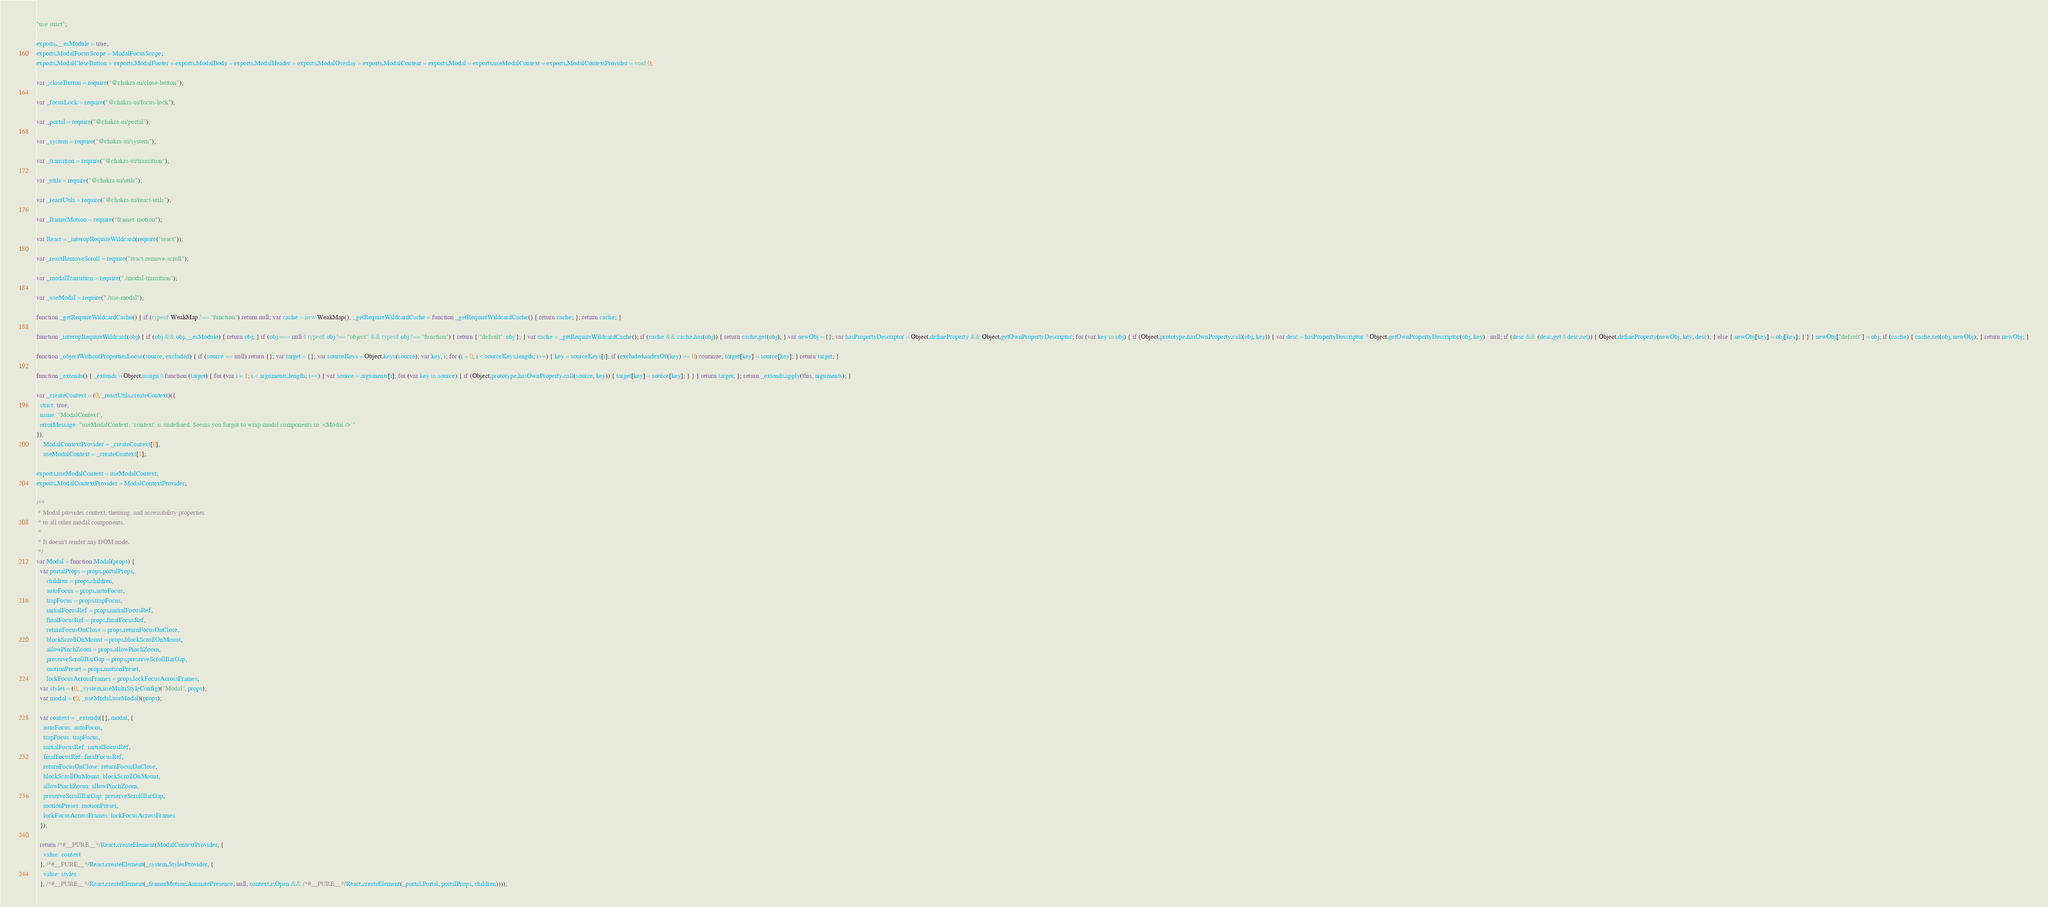Convert code to text. <code><loc_0><loc_0><loc_500><loc_500><_JavaScript_>"use strict";

exports.__esModule = true;
exports.ModalFocusScope = ModalFocusScope;
exports.ModalCloseButton = exports.ModalFooter = exports.ModalBody = exports.ModalHeader = exports.ModalOverlay = exports.ModalContent = exports.Modal = exports.useModalContext = exports.ModalContextProvider = void 0;

var _closeButton = require("@chakra-ui/close-button");

var _focusLock = require("@chakra-ui/focus-lock");

var _portal = require("@chakra-ui/portal");

var _system = require("@chakra-ui/system");

var _transition = require("@chakra-ui/transition");

var _utils = require("@chakra-ui/utils");

var _reactUtils = require("@chakra-ui/react-utils");

var _framerMotion = require("framer-motion");

var React = _interopRequireWildcard(require("react"));

var _reactRemoveScroll = require("react-remove-scroll");

var _modalTransition = require("./modal-transition");

var _useModal = require("./use-modal");

function _getRequireWildcardCache() { if (typeof WeakMap !== "function") return null; var cache = new WeakMap(); _getRequireWildcardCache = function _getRequireWildcardCache() { return cache; }; return cache; }

function _interopRequireWildcard(obj) { if (obj && obj.__esModule) { return obj; } if (obj === null || typeof obj !== "object" && typeof obj !== "function") { return { "default": obj }; } var cache = _getRequireWildcardCache(); if (cache && cache.has(obj)) { return cache.get(obj); } var newObj = {}; var hasPropertyDescriptor = Object.defineProperty && Object.getOwnPropertyDescriptor; for (var key in obj) { if (Object.prototype.hasOwnProperty.call(obj, key)) { var desc = hasPropertyDescriptor ? Object.getOwnPropertyDescriptor(obj, key) : null; if (desc && (desc.get || desc.set)) { Object.defineProperty(newObj, key, desc); } else { newObj[key] = obj[key]; } } } newObj["default"] = obj; if (cache) { cache.set(obj, newObj); } return newObj; }

function _objectWithoutPropertiesLoose(source, excluded) { if (source == null) return {}; var target = {}; var sourceKeys = Object.keys(source); var key, i; for (i = 0; i < sourceKeys.length; i++) { key = sourceKeys[i]; if (excluded.indexOf(key) >= 0) continue; target[key] = source[key]; } return target; }

function _extends() { _extends = Object.assign || function (target) { for (var i = 1; i < arguments.length; i++) { var source = arguments[i]; for (var key in source) { if (Object.prototype.hasOwnProperty.call(source, key)) { target[key] = source[key]; } } } return target; }; return _extends.apply(this, arguments); }

var _createContext = (0, _reactUtils.createContext)({
  strict: true,
  name: "ModalContext",
  errorMessage: "useModalContext: `context` is undefined. Seems you forgot to wrap modal components in `<Modal />`"
}),
    ModalContextProvider = _createContext[0],
    useModalContext = _createContext[1];

exports.useModalContext = useModalContext;
exports.ModalContextProvider = ModalContextProvider;

/**
 * Modal provides context, theming, and accessibility properties
 * to all other modal components.
 *
 * It doesn't render any DOM node.
 */
var Modal = function Modal(props) {
  var portalProps = props.portalProps,
      children = props.children,
      autoFocus = props.autoFocus,
      trapFocus = props.trapFocus,
      initialFocusRef = props.initialFocusRef,
      finalFocusRef = props.finalFocusRef,
      returnFocusOnClose = props.returnFocusOnClose,
      blockScrollOnMount = props.blockScrollOnMount,
      allowPinchZoom = props.allowPinchZoom,
      preserveScrollBarGap = props.preserveScrollBarGap,
      motionPreset = props.motionPreset,
      lockFocusAcrossFrames = props.lockFocusAcrossFrames;
  var styles = (0, _system.useMultiStyleConfig)("Modal", props);
  var modal = (0, _useModal.useModal)(props);

  var context = _extends({}, modal, {
    autoFocus: autoFocus,
    trapFocus: trapFocus,
    initialFocusRef: initialFocusRef,
    finalFocusRef: finalFocusRef,
    returnFocusOnClose: returnFocusOnClose,
    blockScrollOnMount: blockScrollOnMount,
    allowPinchZoom: allowPinchZoom,
    preserveScrollBarGap: preserveScrollBarGap,
    motionPreset: motionPreset,
    lockFocusAcrossFrames: lockFocusAcrossFrames
  });

  return /*#__PURE__*/React.createElement(ModalContextProvider, {
    value: context
  }, /*#__PURE__*/React.createElement(_system.StylesProvider, {
    value: styles
  }, /*#__PURE__*/React.createElement(_framerMotion.AnimatePresence, null, context.isOpen && /*#__PURE__*/React.createElement(_portal.Portal, portalProps, children))));</code> 